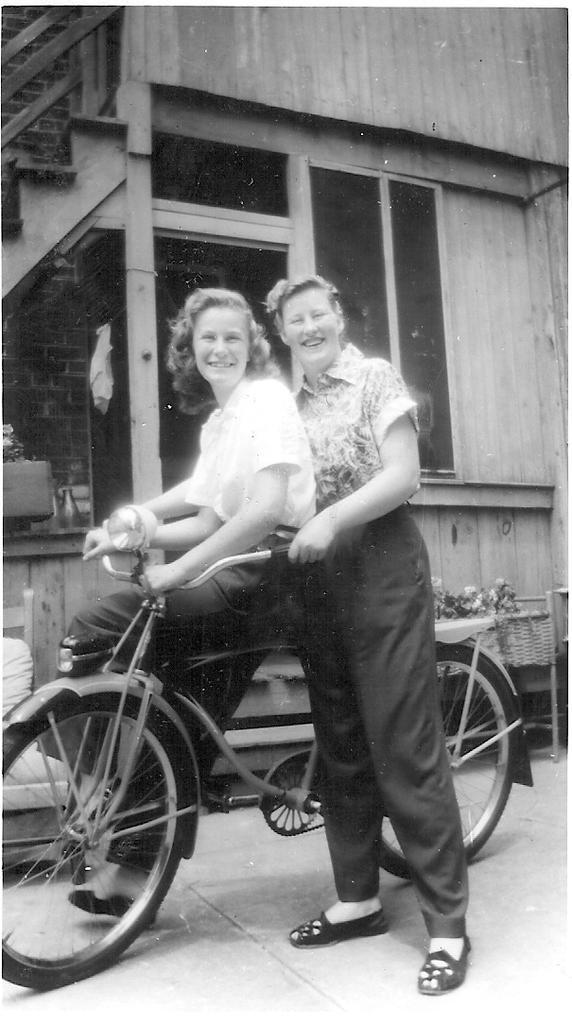How many people are present in the image? There are two people in the image. What are the people doing in the image? One person is seated on a bicycle, and the other person is standing. What can be seen in the background of the image? There are flowers and a building in the background of the image. Are the two people in the image engaging in a kiss? No, there is no indication in the image that the two people are engaging in a kiss. 